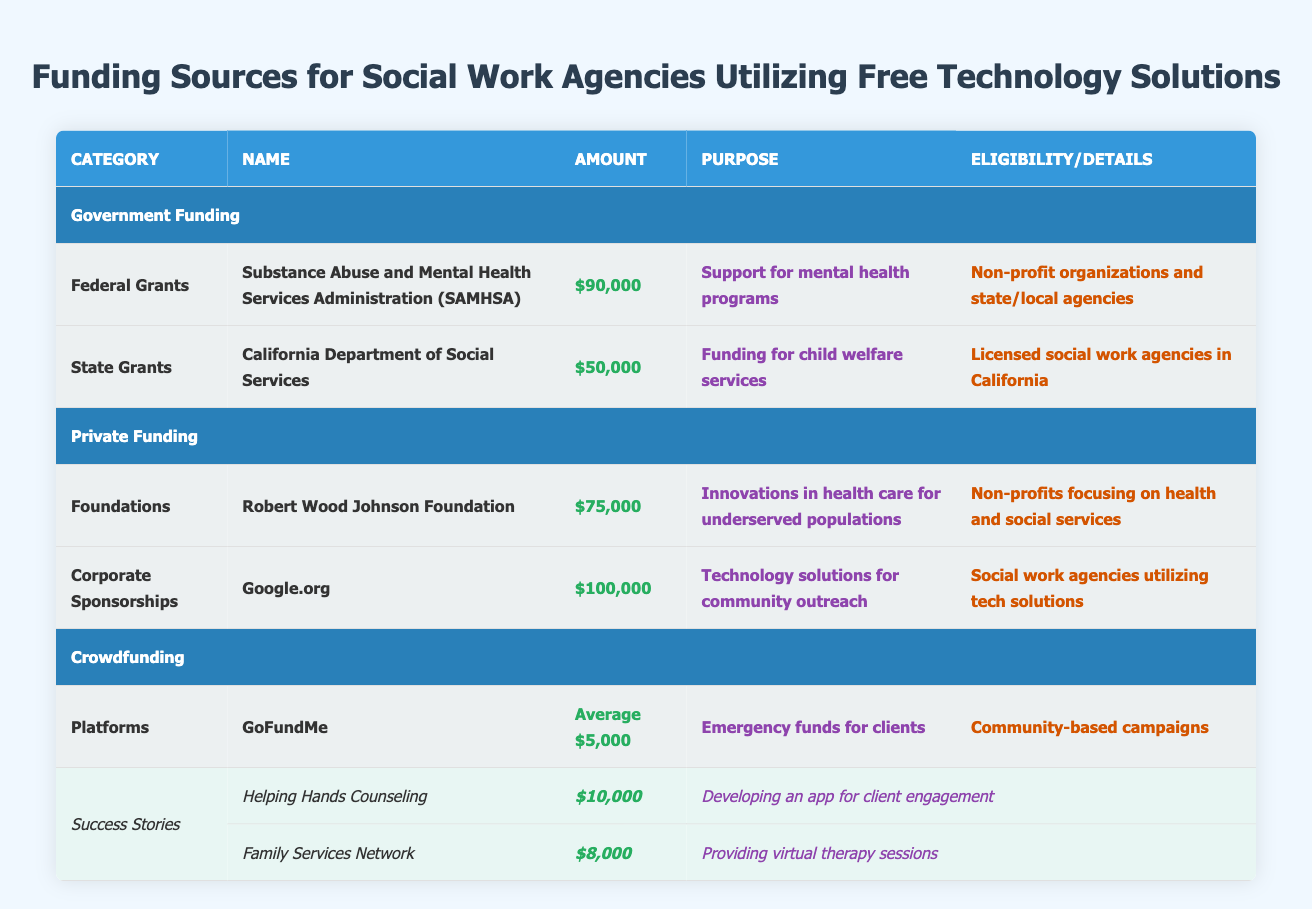What is the total amount of Federal Grants listed? The table shows one Federal Grant, SAMHSA, with an amount of $90,000. Therefore, the total amount for Federal Grants is simply the amount listed.
Answer: $90,000 Are there any corporate sponsorships that offer more funding than federal grants? The corporate sponsorship listed is Google.org with an amount of $100,000, which is greater than SAMHSA's federal grant amount of $90,000. Comparing these values confirms that Google.org offers more funding.
Answer: Yes What is the average funding amount listed for crowdfunding platforms? The table indicates that GoFundMe has an average funding amount of $5,000. Since there is only one crowdfunding platform listed, this is also the average amount.
Answer: $5,000 How much funding was raised by Helping Hands Counseling, and what was the purpose? Helping Hands Counseling raised $10,000 specifically for developing an app for client engagement, as detailed in the success stories section of the table.
Answer: $10,000 for developing an app for client engagement What is the cumulative amount of funding received from Private Funding sources? The amounts listed for Private Funding sources are $75,000 from Robert Wood Johnson Foundation and $100,000 from Google.org. Adding these together gives $75,000 + $100,000 = $175,000.
Answer: $175,000 Is the California Department of Social Services eligible to provide funding for non-profit organizations outside of California? The eligibility specified for the California Department of Social Services funding clearly states it is for "Licensed social work agencies in California." Therefore, the statement is false.
Answer: No What is the purpose of the funding provided by the Robert Wood Johnson Foundation? The table states that the purpose of the funding from the Robert Wood Johnson Foundation is "Innovations in health care for underserved populations." This is a direct read from the table.
Answer: Innovations in health care for underserved populations Which agency raised more funds, Helping Hands Counseling or Family Services Network? Helping Hands Counseling raised $10,000 while Family Services Network raised $8,000. Comparing these values, $10,000 is greater than $8,000 indicating that Helping Hands Counseling raised more funds.
Answer: Helping Hands Counseling 